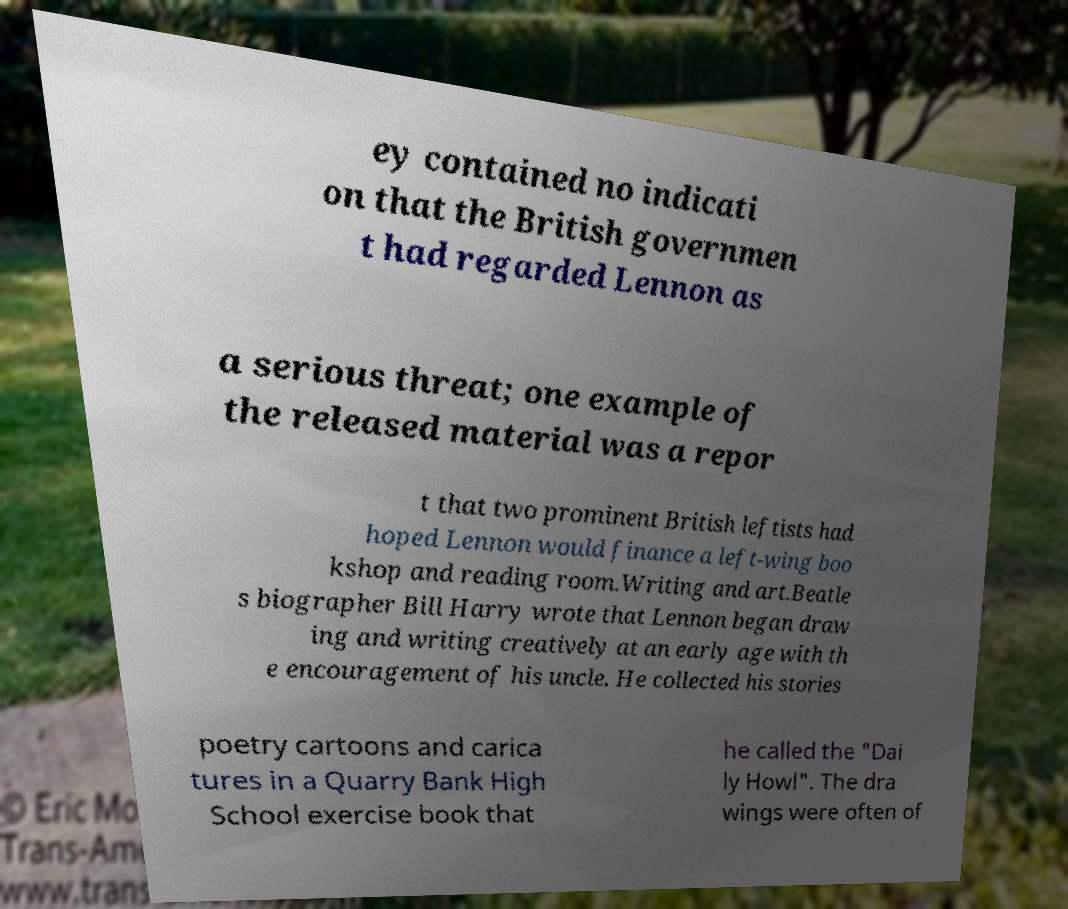Please read and relay the text visible in this image. What does it say? ey contained no indicati on that the British governmen t had regarded Lennon as a serious threat; one example of the released material was a repor t that two prominent British leftists had hoped Lennon would finance a left-wing boo kshop and reading room.Writing and art.Beatle s biographer Bill Harry wrote that Lennon began draw ing and writing creatively at an early age with th e encouragement of his uncle. He collected his stories poetry cartoons and carica tures in a Quarry Bank High School exercise book that he called the "Dai ly Howl". The dra wings were often of 